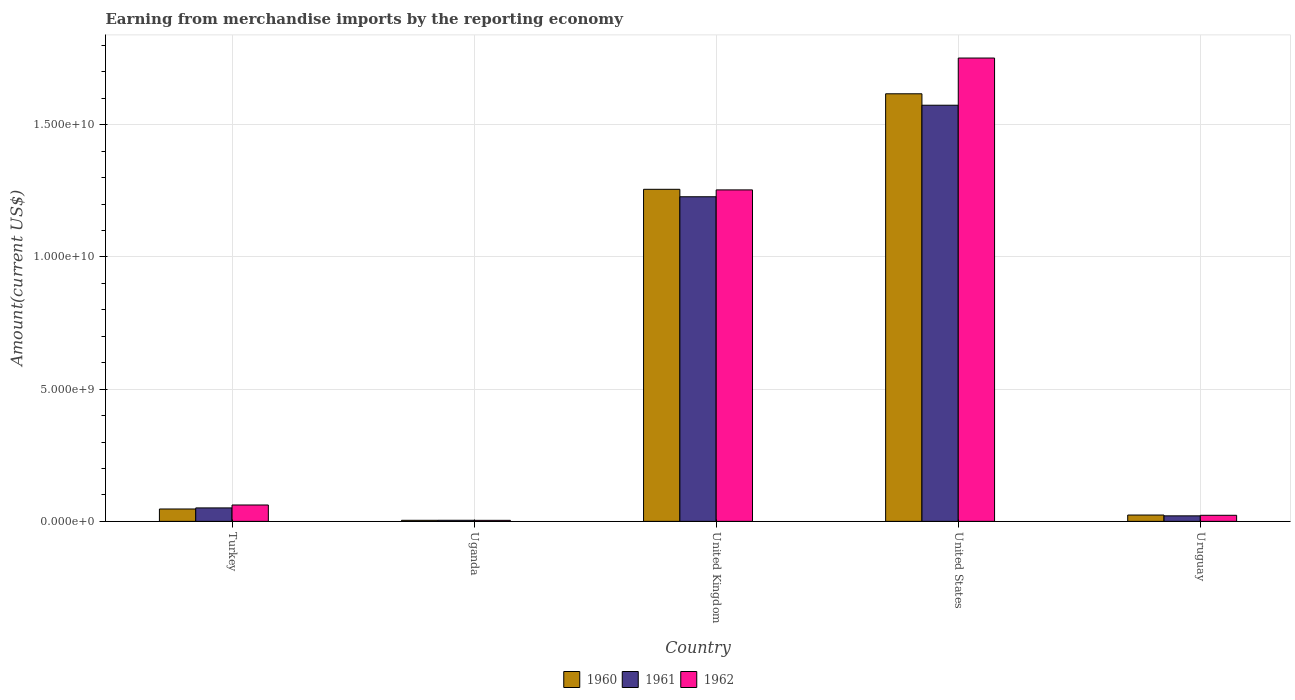How many different coloured bars are there?
Ensure brevity in your answer.  3. How many groups of bars are there?
Keep it short and to the point. 5. Are the number of bars on each tick of the X-axis equal?
Give a very brief answer. Yes. What is the amount earned from merchandise imports in 1962 in United Kingdom?
Your answer should be compact. 1.25e+1. Across all countries, what is the maximum amount earned from merchandise imports in 1962?
Make the answer very short. 1.75e+1. Across all countries, what is the minimum amount earned from merchandise imports in 1962?
Your answer should be compact. 3.90e+07. In which country was the amount earned from merchandise imports in 1960 minimum?
Make the answer very short. Uganda. What is the total amount earned from merchandise imports in 1960 in the graph?
Your response must be concise. 2.95e+1. What is the difference between the amount earned from merchandise imports in 1961 in United States and that in Uruguay?
Keep it short and to the point. 1.55e+1. What is the difference between the amount earned from merchandise imports in 1962 in Uruguay and the amount earned from merchandise imports in 1961 in Turkey?
Keep it short and to the point. -2.79e+08. What is the average amount earned from merchandise imports in 1960 per country?
Give a very brief answer. 5.90e+09. What is the difference between the amount earned from merchandise imports of/in 1962 and amount earned from merchandise imports of/in 1961 in United Kingdom?
Make the answer very short. 2.59e+08. In how many countries, is the amount earned from merchandise imports in 1960 greater than 7000000000 US$?
Provide a short and direct response. 2. What is the ratio of the amount earned from merchandise imports in 1960 in Uganda to that in United Kingdom?
Give a very brief answer. 0. What is the difference between the highest and the second highest amount earned from merchandise imports in 1960?
Make the answer very short. 3.61e+09. What is the difference between the highest and the lowest amount earned from merchandise imports in 1961?
Give a very brief answer. 1.57e+1. Is it the case that in every country, the sum of the amount earned from merchandise imports in 1962 and amount earned from merchandise imports in 1961 is greater than the amount earned from merchandise imports in 1960?
Make the answer very short. Yes. How many bars are there?
Offer a terse response. 15. Are all the bars in the graph horizontal?
Keep it short and to the point. No. How many countries are there in the graph?
Your answer should be very brief. 5. Are the values on the major ticks of Y-axis written in scientific E-notation?
Provide a short and direct response. Yes. Where does the legend appear in the graph?
Provide a succinct answer. Bottom center. How are the legend labels stacked?
Provide a short and direct response. Horizontal. What is the title of the graph?
Provide a short and direct response. Earning from merchandise imports by the reporting economy. What is the label or title of the X-axis?
Your response must be concise. Country. What is the label or title of the Y-axis?
Keep it short and to the point. Amount(current US$). What is the Amount(current US$) of 1960 in Turkey?
Provide a short and direct response. 4.68e+08. What is the Amount(current US$) in 1961 in Turkey?
Keep it short and to the point. 5.09e+08. What is the Amount(current US$) of 1962 in Turkey?
Provide a short and direct response. 6.19e+08. What is the Amount(current US$) in 1960 in Uganda?
Your response must be concise. 4.01e+07. What is the Amount(current US$) of 1961 in Uganda?
Your answer should be very brief. 4.11e+07. What is the Amount(current US$) in 1962 in Uganda?
Give a very brief answer. 3.90e+07. What is the Amount(current US$) of 1960 in United Kingdom?
Provide a short and direct response. 1.26e+1. What is the Amount(current US$) in 1961 in United Kingdom?
Your answer should be very brief. 1.23e+1. What is the Amount(current US$) in 1962 in United Kingdom?
Provide a short and direct response. 1.25e+1. What is the Amount(current US$) of 1960 in United States?
Ensure brevity in your answer.  1.62e+1. What is the Amount(current US$) in 1961 in United States?
Your response must be concise. 1.57e+1. What is the Amount(current US$) of 1962 in United States?
Ensure brevity in your answer.  1.75e+1. What is the Amount(current US$) in 1960 in Uruguay?
Make the answer very short. 2.39e+08. What is the Amount(current US$) of 1961 in Uruguay?
Ensure brevity in your answer.  2.08e+08. What is the Amount(current US$) in 1962 in Uruguay?
Offer a terse response. 2.30e+08. Across all countries, what is the maximum Amount(current US$) in 1960?
Your answer should be very brief. 1.62e+1. Across all countries, what is the maximum Amount(current US$) in 1961?
Keep it short and to the point. 1.57e+1. Across all countries, what is the maximum Amount(current US$) of 1962?
Offer a terse response. 1.75e+1. Across all countries, what is the minimum Amount(current US$) in 1960?
Your answer should be compact. 4.01e+07. Across all countries, what is the minimum Amount(current US$) of 1961?
Your answer should be very brief. 4.11e+07. Across all countries, what is the minimum Amount(current US$) in 1962?
Give a very brief answer. 3.90e+07. What is the total Amount(current US$) of 1960 in the graph?
Your answer should be very brief. 2.95e+1. What is the total Amount(current US$) of 1961 in the graph?
Your answer should be compact. 2.88e+1. What is the total Amount(current US$) of 1962 in the graph?
Provide a succinct answer. 3.09e+1. What is the difference between the Amount(current US$) of 1960 in Turkey and that in Uganda?
Provide a succinct answer. 4.28e+08. What is the difference between the Amount(current US$) of 1961 in Turkey and that in Uganda?
Keep it short and to the point. 4.68e+08. What is the difference between the Amount(current US$) in 1962 in Turkey and that in Uganda?
Offer a terse response. 5.80e+08. What is the difference between the Amount(current US$) of 1960 in Turkey and that in United Kingdom?
Give a very brief answer. -1.21e+1. What is the difference between the Amount(current US$) of 1961 in Turkey and that in United Kingdom?
Your answer should be very brief. -1.18e+1. What is the difference between the Amount(current US$) of 1962 in Turkey and that in United Kingdom?
Provide a succinct answer. -1.19e+1. What is the difference between the Amount(current US$) of 1960 in Turkey and that in United States?
Provide a short and direct response. -1.57e+1. What is the difference between the Amount(current US$) in 1961 in Turkey and that in United States?
Make the answer very short. -1.52e+1. What is the difference between the Amount(current US$) in 1962 in Turkey and that in United States?
Provide a succinct answer. -1.69e+1. What is the difference between the Amount(current US$) of 1960 in Turkey and that in Uruguay?
Keep it short and to the point. 2.29e+08. What is the difference between the Amount(current US$) in 1961 in Turkey and that in Uruguay?
Make the answer very short. 3.00e+08. What is the difference between the Amount(current US$) of 1962 in Turkey and that in Uruguay?
Keep it short and to the point. 3.89e+08. What is the difference between the Amount(current US$) in 1960 in Uganda and that in United Kingdom?
Your answer should be very brief. -1.25e+1. What is the difference between the Amount(current US$) of 1961 in Uganda and that in United Kingdom?
Offer a terse response. -1.22e+1. What is the difference between the Amount(current US$) of 1962 in Uganda and that in United Kingdom?
Ensure brevity in your answer.  -1.25e+1. What is the difference between the Amount(current US$) of 1960 in Uganda and that in United States?
Give a very brief answer. -1.61e+1. What is the difference between the Amount(current US$) in 1961 in Uganda and that in United States?
Offer a very short reply. -1.57e+1. What is the difference between the Amount(current US$) of 1962 in Uganda and that in United States?
Provide a succinct answer. -1.75e+1. What is the difference between the Amount(current US$) of 1960 in Uganda and that in Uruguay?
Provide a succinct answer. -1.99e+08. What is the difference between the Amount(current US$) of 1961 in Uganda and that in Uruguay?
Give a very brief answer. -1.67e+08. What is the difference between the Amount(current US$) of 1962 in Uganda and that in Uruguay?
Give a very brief answer. -1.91e+08. What is the difference between the Amount(current US$) in 1960 in United Kingdom and that in United States?
Your answer should be very brief. -3.61e+09. What is the difference between the Amount(current US$) of 1961 in United Kingdom and that in United States?
Ensure brevity in your answer.  -3.46e+09. What is the difference between the Amount(current US$) of 1962 in United Kingdom and that in United States?
Ensure brevity in your answer.  -4.99e+09. What is the difference between the Amount(current US$) of 1960 in United Kingdom and that in Uruguay?
Make the answer very short. 1.23e+1. What is the difference between the Amount(current US$) of 1961 in United Kingdom and that in Uruguay?
Give a very brief answer. 1.21e+1. What is the difference between the Amount(current US$) in 1962 in United Kingdom and that in Uruguay?
Keep it short and to the point. 1.23e+1. What is the difference between the Amount(current US$) of 1960 in United States and that in Uruguay?
Offer a terse response. 1.59e+1. What is the difference between the Amount(current US$) in 1961 in United States and that in Uruguay?
Your answer should be compact. 1.55e+1. What is the difference between the Amount(current US$) of 1962 in United States and that in Uruguay?
Offer a terse response. 1.73e+1. What is the difference between the Amount(current US$) in 1960 in Turkey and the Amount(current US$) in 1961 in Uganda?
Provide a short and direct response. 4.27e+08. What is the difference between the Amount(current US$) of 1960 in Turkey and the Amount(current US$) of 1962 in Uganda?
Offer a terse response. 4.29e+08. What is the difference between the Amount(current US$) in 1961 in Turkey and the Amount(current US$) in 1962 in Uganda?
Offer a very short reply. 4.70e+08. What is the difference between the Amount(current US$) of 1960 in Turkey and the Amount(current US$) of 1961 in United Kingdom?
Your answer should be compact. -1.18e+1. What is the difference between the Amount(current US$) in 1960 in Turkey and the Amount(current US$) in 1962 in United Kingdom?
Provide a short and direct response. -1.21e+1. What is the difference between the Amount(current US$) of 1961 in Turkey and the Amount(current US$) of 1962 in United Kingdom?
Your answer should be very brief. -1.20e+1. What is the difference between the Amount(current US$) of 1960 in Turkey and the Amount(current US$) of 1961 in United States?
Your response must be concise. -1.53e+1. What is the difference between the Amount(current US$) in 1960 in Turkey and the Amount(current US$) in 1962 in United States?
Provide a short and direct response. -1.71e+1. What is the difference between the Amount(current US$) of 1961 in Turkey and the Amount(current US$) of 1962 in United States?
Your answer should be very brief. -1.70e+1. What is the difference between the Amount(current US$) in 1960 in Turkey and the Amount(current US$) in 1961 in Uruguay?
Keep it short and to the point. 2.59e+08. What is the difference between the Amount(current US$) in 1960 in Turkey and the Amount(current US$) in 1962 in Uruguay?
Give a very brief answer. 2.38e+08. What is the difference between the Amount(current US$) in 1961 in Turkey and the Amount(current US$) in 1962 in Uruguay?
Provide a short and direct response. 2.79e+08. What is the difference between the Amount(current US$) in 1960 in Uganda and the Amount(current US$) in 1961 in United Kingdom?
Ensure brevity in your answer.  -1.22e+1. What is the difference between the Amount(current US$) of 1960 in Uganda and the Amount(current US$) of 1962 in United Kingdom?
Offer a very short reply. -1.25e+1. What is the difference between the Amount(current US$) of 1961 in Uganda and the Amount(current US$) of 1962 in United Kingdom?
Your answer should be very brief. -1.25e+1. What is the difference between the Amount(current US$) of 1960 in Uganda and the Amount(current US$) of 1961 in United States?
Your answer should be very brief. -1.57e+1. What is the difference between the Amount(current US$) of 1960 in Uganda and the Amount(current US$) of 1962 in United States?
Ensure brevity in your answer.  -1.75e+1. What is the difference between the Amount(current US$) of 1961 in Uganda and the Amount(current US$) of 1962 in United States?
Provide a succinct answer. -1.75e+1. What is the difference between the Amount(current US$) of 1960 in Uganda and the Amount(current US$) of 1961 in Uruguay?
Offer a very short reply. -1.68e+08. What is the difference between the Amount(current US$) of 1960 in Uganda and the Amount(current US$) of 1962 in Uruguay?
Offer a very short reply. -1.90e+08. What is the difference between the Amount(current US$) of 1961 in Uganda and the Amount(current US$) of 1962 in Uruguay?
Provide a short and direct response. -1.89e+08. What is the difference between the Amount(current US$) of 1960 in United Kingdom and the Amount(current US$) of 1961 in United States?
Your response must be concise. -3.18e+09. What is the difference between the Amount(current US$) in 1960 in United Kingdom and the Amount(current US$) in 1962 in United States?
Your response must be concise. -4.96e+09. What is the difference between the Amount(current US$) in 1961 in United Kingdom and the Amount(current US$) in 1962 in United States?
Provide a succinct answer. -5.25e+09. What is the difference between the Amount(current US$) of 1960 in United Kingdom and the Amount(current US$) of 1961 in Uruguay?
Give a very brief answer. 1.24e+1. What is the difference between the Amount(current US$) of 1960 in United Kingdom and the Amount(current US$) of 1962 in Uruguay?
Your answer should be compact. 1.23e+1. What is the difference between the Amount(current US$) of 1961 in United Kingdom and the Amount(current US$) of 1962 in Uruguay?
Ensure brevity in your answer.  1.20e+1. What is the difference between the Amount(current US$) of 1960 in United States and the Amount(current US$) of 1961 in Uruguay?
Provide a short and direct response. 1.60e+1. What is the difference between the Amount(current US$) in 1960 in United States and the Amount(current US$) in 1962 in Uruguay?
Your answer should be compact. 1.59e+1. What is the difference between the Amount(current US$) in 1961 in United States and the Amount(current US$) in 1962 in Uruguay?
Offer a very short reply. 1.55e+1. What is the average Amount(current US$) in 1960 per country?
Offer a terse response. 5.90e+09. What is the average Amount(current US$) in 1961 per country?
Your answer should be compact. 5.75e+09. What is the average Amount(current US$) of 1962 per country?
Your answer should be very brief. 6.19e+09. What is the difference between the Amount(current US$) in 1960 and Amount(current US$) in 1961 in Turkey?
Your answer should be compact. -4.11e+07. What is the difference between the Amount(current US$) of 1960 and Amount(current US$) of 1962 in Turkey?
Make the answer very short. -1.52e+08. What is the difference between the Amount(current US$) of 1961 and Amount(current US$) of 1962 in Turkey?
Your answer should be compact. -1.10e+08. What is the difference between the Amount(current US$) of 1960 and Amount(current US$) of 1962 in Uganda?
Make the answer very short. 1.10e+06. What is the difference between the Amount(current US$) in 1961 and Amount(current US$) in 1962 in Uganda?
Provide a short and direct response. 2.10e+06. What is the difference between the Amount(current US$) of 1960 and Amount(current US$) of 1961 in United Kingdom?
Offer a very short reply. 2.82e+08. What is the difference between the Amount(current US$) in 1960 and Amount(current US$) in 1962 in United Kingdom?
Your response must be concise. 2.22e+07. What is the difference between the Amount(current US$) of 1961 and Amount(current US$) of 1962 in United Kingdom?
Your response must be concise. -2.59e+08. What is the difference between the Amount(current US$) in 1960 and Amount(current US$) in 1961 in United States?
Offer a terse response. 4.32e+08. What is the difference between the Amount(current US$) of 1960 and Amount(current US$) of 1962 in United States?
Give a very brief answer. -1.35e+09. What is the difference between the Amount(current US$) of 1961 and Amount(current US$) of 1962 in United States?
Offer a terse response. -1.78e+09. What is the difference between the Amount(current US$) in 1960 and Amount(current US$) in 1961 in Uruguay?
Offer a terse response. 3.08e+07. What is the difference between the Amount(current US$) in 1960 and Amount(current US$) in 1962 in Uruguay?
Provide a succinct answer. 9.10e+06. What is the difference between the Amount(current US$) in 1961 and Amount(current US$) in 1962 in Uruguay?
Ensure brevity in your answer.  -2.17e+07. What is the ratio of the Amount(current US$) of 1960 in Turkey to that in Uganda?
Your answer should be compact. 11.66. What is the ratio of the Amount(current US$) of 1961 in Turkey to that in Uganda?
Offer a very short reply. 12.38. What is the ratio of the Amount(current US$) of 1962 in Turkey to that in Uganda?
Your answer should be very brief. 15.88. What is the ratio of the Amount(current US$) in 1960 in Turkey to that in United Kingdom?
Your response must be concise. 0.04. What is the ratio of the Amount(current US$) of 1961 in Turkey to that in United Kingdom?
Give a very brief answer. 0.04. What is the ratio of the Amount(current US$) of 1962 in Turkey to that in United Kingdom?
Offer a very short reply. 0.05. What is the ratio of the Amount(current US$) of 1960 in Turkey to that in United States?
Offer a terse response. 0.03. What is the ratio of the Amount(current US$) of 1961 in Turkey to that in United States?
Make the answer very short. 0.03. What is the ratio of the Amount(current US$) in 1962 in Turkey to that in United States?
Ensure brevity in your answer.  0.04. What is the ratio of the Amount(current US$) in 1960 in Turkey to that in Uruguay?
Provide a short and direct response. 1.96. What is the ratio of the Amount(current US$) in 1961 in Turkey to that in Uruguay?
Offer a terse response. 2.44. What is the ratio of the Amount(current US$) of 1962 in Turkey to that in Uruguay?
Give a very brief answer. 2.69. What is the ratio of the Amount(current US$) in 1960 in Uganda to that in United Kingdom?
Your answer should be very brief. 0. What is the ratio of the Amount(current US$) of 1961 in Uganda to that in United Kingdom?
Your answer should be very brief. 0. What is the ratio of the Amount(current US$) in 1962 in Uganda to that in United Kingdom?
Offer a very short reply. 0. What is the ratio of the Amount(current US$) of 1960 in Uganda to that in United States?
Ensure brevity in your answer.  0. What is the ratio of the Amount(current US$) of 1961 in Uganda to that in United States?
Your answer should be very brief. 0. What is the ratio of the Amount(current US$) in 1962 in Uganda to that in United States?
Provide a succinct answer. 0. What is the ratio of the Amount(current US$) of 1960 in Uganda to that in Uruguay?
Offer a very short reply. 0.17. What is the ratio of the Amount(current US$) in 1961 in Uganda to that in Uruguay?
Your answer should be compact. 0.2. What is the ratio of the Amount(current US$) in 1962 in Uganda to that in Uruguay?
Your answer should be compact. 0.17. What is the ratio of the Amount(current US$) of 1960 in United Kingdom to that in United States?
Keep it short and to the point. 0.78. What is the ratio of the Amount(current US$) in 1961 in United Kingdom to that in United States?
Offer a very short reply. 0.78. What is the ratio of the Amount(current US$) in 1962 in United Kingdom to that in United States?
Provide a succinct answer. 0.72. What is the ratio of the Amount(current US$) in 1960 in United Kingdom to that in Uruguay?
Your answer should be compact. 52.52. What is the ratio of the Amount(current US$) of 1961 in United Kingdom to that in Uruguay?
Your answer should be compact. 58.94. What is the ratio of the Amount(current US$) in 1962 in United Kingdom to that in Uruguay?
Your response must be concise. 54.51. What is the ratio of the Amount(current US$) in 1960 in United States to that in Uruguay?
Your answer should be very brief. 67.63. What is the ratio of the Amount(current US$) in 1961 in United States to that in Uruguay?
Offer a very short reply. 75.56. What is the ratio of the Amount(current US$) in 1962 in United States to that in Uruguay?
Offer a very short reply. 76.19. What is the difference between the highest and the second highest Amount(current US$) of 1960?
Provide a short and direct response. 3.61e+09. What is the difference between the highest and the second highest Amount(current US$) of 1961?
Make the answer very short. 3.46e+09. What is the difference between the highest and the second highest Amount(current US$) in 1962?
Provide a short and direct response. 4.99e+09. What is the difference between the highest and the lowest Amount(current US$) of 1960?
Offer a terse response. 1.61e+1. What is the difference between the highest and the lowest Amount(current US$) of 1961?
Your answer should be very brief. 1.57e+1. What is the difference between the highest and the lowest Amount(current US$) of 1962?
Your response must be concise. 1.75e+1. 